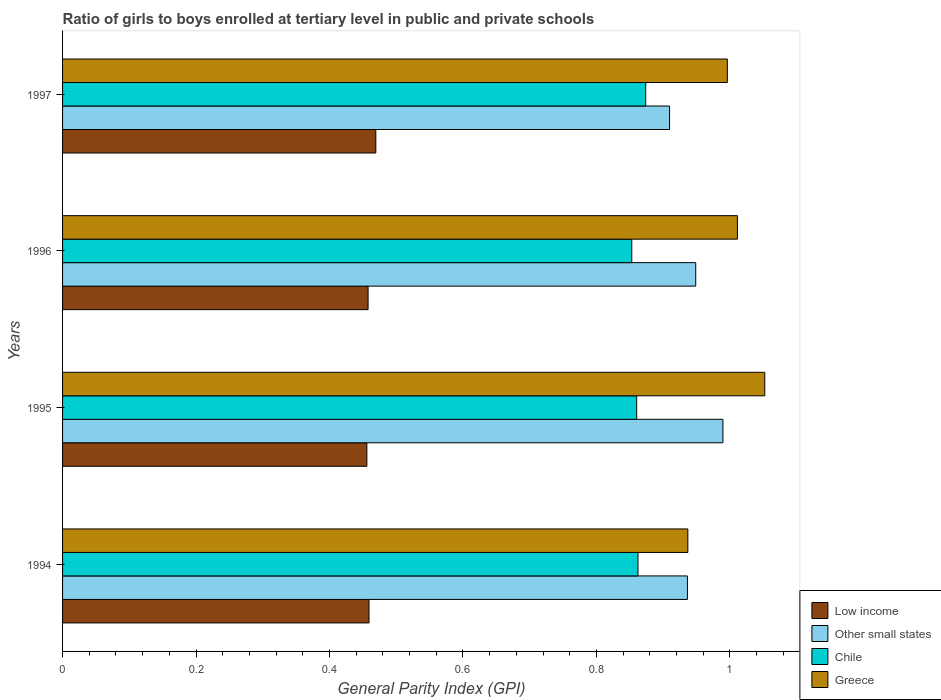Are the number of bars per tick equal to the number of legend labels?
Provide a succinct answer. Yes. Are the number of bars on each tick of the Y-axis equal?
Offer a terse response. Yes. How many bars are there on the 2nd tick from the bottom?
Ensure brevity in your answer.  4. What is the label of the 1st group of bars from the top?
Your response must be concise. 1997. In how many cases, is the number of bars for a given year not equal to the number of legend labels?
Offer a terse response. 0. What is the general parity index in Other small states in 1994?
Provide a succinct answer. 0.94. Across all years, what is the maximum general parity index in Other small states?
Keep it short and to the point. 0.99. Across all years, what is the minimum general parity index in Low income?
Ensure brevity in your answer.  0.46. In which year was the general parity index in Low income maximum?
Provide a succinct answer. 1997. What is the total general parity index in Greece in the graph?
Your answer should be very brief. 4. What is the difference between the general parity index in Other small states in 1994 and that in 1996?
Provide a succinct answer. -0.01. What is the difference between the general parity index in Greece in 1994 and the general parity index in Chile in 1995?
Your answer should be very brief. 0.08. What is the average general parity index in Low income per year?
Offer a terse response. 0.46. In the year 1995, what is the difference between the general parity index in Chile and general parity index in Low income?
Ensure brevity in your answer.  0.4. What is the ratio of the general parity index in Greece in 1996 to that in 1997?
Offer a very short reply. 1.02. Is the general parity index in Greece in 1994 less than that in 1995?
Provide a succinct answer. Yes. What is the difference between the highest and the second highest general parity index in Low income?
Keep it short and to the point. 0.01. What is the difference between the highest and the lowest general parity index in Other small states?
Offer a terse response. 0.08. Is the sum of the general parity index in Low income in 1994 and 1996 greater than the maximum general parity index in Other small states across all years?
Give a very brief answer. No. What does the 2nd bar from the bottom in 1997 represents?
Your answer should be compact. Other small states. Is it the case that in every year, the sum of the general parity index in Chile and general parity index in Other small states is greater than the general parity index in Low income?
Ensure brevity in your answer.  Yes. How many years are there in the graph?
Offer a terse response. 4. Are the values on the major ticks of X-axis written in scientific E-notation?
Make the answer very short. No. Does the graph contain grids?
Your answer should be very brief. No. Where does the legend appear in the graph?
Offer a terse response. Bottom right. How many legend labels are there?
Keep it short and to the point. 4. What is the title of the graph?
Offer a terse response. Ratio of girls to boys enrolled at tertiary level in public and private schools. What is the label or title of the X-axis?
Your response must be concise. General Parity Index (GPI). What is the label or title of the Y-axis?
Offer a very short reply. Years. What is the General Parity Index (GPI) in Low income in 1994?
Provide a short and direct response. 0.46. What is the General Parity Index (GPI) in Other small states in 1994?
Make the answer very short. 0.94. What is the General Parity Index (GPI) of Chile in 1994?
Offer a terse response. 0.86. What is the General Parity Index (GPI) of Greece in 1994?
Your answer should be very brief. 0.94. What is the General Parity Index (GPI) of Low income in 1995?
Offer a very short reply. 0.46. What is the General Parity Index (GPI) in Other small states in 1995?
Provide a succinct answer. 0.99. What is the General Parity Index (GPI) of Chile in 1995?
Give a very brief answer. 0.86. What is the General Parity Index (GPI) of Greece in 1995?
Offer a terse response. 1.05. What is the General Parity Index (GPI) in Low income in 1996?
Give a very brief answer. 0.46. What is the General Parity Index (GPI) of Other small states in 1996?
Your response must be concise. 0.95. What is the General Parity Index (GPI) of Chile in 1996?
Provide a short and direct response. 0.85. What is the General Parity Index (GPI) of Greece in 1996?
Ensure brevity in your answer.  1.01. What is the General Parity Index (GPI) in Low income in 1997?
Keep it short and to the point. 0.47. What is the General Parity Index (GPI) of Other small states in 1997?
Ensure brevity in your answer.  0.91. What is the General Parity Index (GPI) in Chile in 1997?
Your answer should be compact. 0.87. What is the General Parity Index (GPI) of Greece in 1997?
Give a very brief answer. 1. Across all years, what is the maximum General Parity Index (GPI) of Low income?
Provide a short and direct response. 0.47. Across all years, what is the maximum General Parity Index (GPI) of Other small states?
Ensure brevity in your answer.  0.99. Across all years, what is the maximum General Parity Index (GPI) in Chile?
Offer a very short reply. 0.87. Across all years, what is the maximum General Parity Index (GPI) in Greece?
Your answer should be compact. 1.05. Across all years, what is the minimum General Parity Index (GPI) of Low income?
Ensure brevity in your answer.  0.46. Across all years, what is the minimum General Parity Index (GPI) of Other small states?
Offer a very short reply. 0.91. Across all years, what is the minimum General Parity Index (GPI) in Chile?
Give a very brief answer. 0.85. Across all years, what is the minimum General Parity Index (GPI) of Greece?
Give a very brief answer. 0.94. What is the total General Parity Index (GPI) of Low income in the graph?
Give a very brief answer. 1.84. What is the total General Parity Index (GPI) in Other small states in the graph?
Keep it short and to the point. 3.78. What is the total General Parity Index (GPI) in Chile in the graph?
Provide a short and direct response. 3.45. What is the total General Parity Index (GPI) in Greece in the graph?
Provide a short and direct response. 4. What is the difference between the General Parity Index (GPI) of Low income in 1994 and that in 1995?
Ensure brevity in your answer.  0. What is the difference between the General Parity Index (GPI) of Other small states in 1994 and that in 1995?
Provide a short and direct response. -0.05. What is the difference between the General Parity Index (GPI) of Chile in 1994 and that in 1995?
Provide a short and direct response. 0. What is the difference between the General Parity Index (GPI) of Greece in 1994 and that in 1995?
Offer a terse response. -0.12. What is the difference between the General Parity Index (GPI) of Low income in 1994 and that in 1996?
Give a very brief answer. 0. What is the difference between the General Parity Index (GPI) in Other small states in 1994 and that in 1996?
Offer a very short reply. -0.01. What is the difference between the General Parity Index (GPI) of Chile in 1994 and that in 1996?
Keep it short and to the point. 0.01. What is the difference between the General Parity Index (GPI) of Greece in 1994 and that in 1996?
Give a very brief answer. -0.07. What is the difference between the General Parity Index (GPI) in Low income in 1994 and that in 1997?
Ensure brevity in your answer.  -0.01. What is the difference between the General Parity Index (GPI) in Other small states in 1994 and that in 1997?
Provide a succinct answer. 0.03. What is the difference between the General Parity Index (GPI) in Chile in 1994 and that in 1997?
Offer a very short reply. -0.01. What is the difference between the General Parity Index (GPI) of Greece in 1994 and that in 1997?
Provide a succinct answer. -0.06. What is the difference between the General Parity Index (GPI) of Low income in 1995 and that in 1996?
Make the answer very short. -0. What is the difference between the General Parity Index (GPI) of Other small states in 1995 and that in 1996?
Keep it short and to the point. 0.04. What is the difference between the General Parity Index (GPI) in Chile in 1995 and that in 1996?
Your answer should be very brief. 0.01. What is the difference between the General Parity Index (GPI) of Greece in 1995 and that in 1996?
Make the answer very short. 0.04. What is the difference between the General Parity Index (GPI) in Low income in 1995 and that in 1997?
Ensure brevity in your answer.  -0.01. What is the difference between the General Parity Index (GPI) in Other small states in 1995 and that in 1997?
Offer a terse response. 0.08. What is the difference between the General Parity Index (GPI) in Chile in 1995 and that in 1997?
Keep it short and to the point. -0.01. What is the difference between the General Parity Index (GPI) in Greece in 1995 and that in 1997?
Ensure brevity in your answer.  0.06. What is the difference between the General Parity Index (GPI) in Low income in 1996 and that in 1997?
Provide a succinct answer. -0.01. What is the difference between the General Parity Index (GPI) of Other small states in 1996 and that in 1997?
Ensure brevity in your answer.  0.04. What is the difference between the General Parity Index (GPI) of Chile in 1996 and that in 1997?
Your answer should be compact. -0.02. What is the difference between the General Parity Index (GPI) of Greece in 1996 and that in 1997?
Make the answer very short. 0.02. What is the difference between the General Parity Index (GPI) of Low income in 1994 and the General Parity Index (GPI) of Other small states in 1995?
Provide a short and direct response. -0.53. What is the difference between the General Parity Index (GPI) in Low income in 1994 and the General Parity Index (GPI) in Chile in 1995?
Offer a terse response. -0.4. What is the difference between the General Parity Index (GPI) of Low income in 1994 and the General Parity Index (GPI) of Greece in 1995?
Your answer should be compact. -0.59. What is the difference between the General Parity Index (GPI) in Other small states in 1994 and the General Parity Index (GPI) in Chile in 1995?
Your answer should be very brief. 0.08. What is the difference between the General Parity Index (GPI) in Other small states in 1994 and the General Parity Index (GPI) in Greece in 1995?
Provide a short and direct response. -0.12. What is the difference between the General Parity Index (GPI) in Chile in 1994 and the General Parity Index (GPI) in Greece in 1995?
Offer a terse response. -0.19. What is the difference between the General Parity Index (GPI) of Low income in 1994 and the General Parity Index (GPI) of Other small states in 1996?
Provide a succinct answer. -0.49. What is the difference between the General Parity Index (GPI) in Low income in 1994 and the General Parity Index (GPI) in Chile in 1996?
Your answer should be very brief. -0.39. What is the difference between the General Parity Index (GPI) in Low income in 1994 and the General Parity Index (GPI) in Greece in 1996?
Your response must be concise. -0.55. What is the difference between the General Parity Index (GPI) in Other small states in 1994 and the General Parity Index (GPI) in Chile in 1996?
Keep it short and to the point. 0.08. What is the difference between the General Parity Index (GPI) in Other small states in 1994 and the General Parity Index (GPI) in Greece in 1996?
Offer a terse response. -0.07. What is the difference between the General Parity Index (GPI) of Chile in 1994 and the General Parity Index (GPI) of Greece in 1996?
Ensure brevity in your answer.  -0.15. What is the difference between the General Parity Index (GPI) in Low income in 1994 and the General Parity Index (GPI) in Other small states in 1997?
Offer a very short reply. -0.45. What is the difference between the General Parity Index (GPI) in Low income in 1994 and the General Parity Index (GPI) in Chile in 1997?
Keep it short and to the point. -0.41. What is the difference between the General Parity Index (GPI) in Low income in 1994 and the General Parity Index (GPI) in Greece in 1997?
Keep it short and to the point. -0.54. What is the difference between the General Parity Index (GPI) in Other small states in 1994 and the General Parity Index (GPI) in Chile in 1997?
Provide a succinct answer. 0.06. What is the difference between the General Parity Index (GPI) of Other small states in 1994 and the General Parity Index (GPI) of Greece in 1997?
Offer a terse response. -0.06. What is the difference between the General Parity Index (GPI) in Chile in 1994 and the General Parity Index (GPI) in Greece in 1997?
Offer a terse response. -0.13. What is the difference between the General Parity Index (GPI) of Low income in 1995 and the General Parity Index (GPI) of Other small states in 1996?
Make the answer very short. -0.49. What is the difference between the General Parity Index (GPI) in Low income in 1995 and the General Parity Index (GPI) in Chile in 1996?
Offer a terse response. -0.4. What is the difference between the General Parity Index (GPI) of Low income in 1995 and the General Parity Index (GPI) of Greece in 1996?
Your answer should be compact. -0.56. What is the difference between the General Parity Index (GPI) of Other small states in 1995 and the General Parity Index (GPI) of Chile in 1996?
Offer a terse response. 0.14. What is the difference between the General Parity Index (GPI) in Other small states in 1995 and the General Parity Index (GPI) in Greece in 1996?
Your answer should be compact. -0.02. What is the difference between the General Parity Index (GPI) of Chile in 1995 and the General Parity Index (GPI) of Greece in 1996?
Make the answer very short. -0.15. What is the difference between the General Parity Index (GPI) in Low income in 1995 and the General Parity Index (GPI) in Other small states in 1997?
Provide a succinct answer. -0.45. What is the difference between the General Parity Index (GPI) in Low income in 1995 and the General Parity Index (GPI) in Chile in 1997?
Give a very brief answer. -0.42. What is the difference between the General Parity Index (GPI) in Low income in 1995 and the General Parity Index (GPI) in Greece in 1997?
Provide a short and direct response. -0.54. What is the difference between the General Parity Index (GPI) of Other small states in 1995 and the General Parity Index (GPI) of Chile in 1997?
Offer a very short reply. 0.12. What is the difference between the General Parity Index (GPI) in Other small states in 1995 and the General Parity Index (GPI) in Greece in 1997?
Your answer should be compact. -0.01. What is the difference between the General Parity Index (GPI) in Chile in 1995 and the General Parity Index (GPI) in Greece in 1997?
Make the answer very short. -0.14. What is the difference between the General Parity Index (GPI) of Low income in 1996 and the General Parity Index (GPI) of Other small states in 1997?
Keep it short and to the point. -0.45. What is the difference between the General Parity Index (GPI) of Low income in 1996 and the General Parity Index (GPI) of Chile in 1997?
Your answer should be compact. -0.42. What is the difference between the General Parity Index (GPI) in Low income in 1996 and the General Parity Index (GPI) in Greece in 1997?
Offer a terse response. -0.54. What is the difference between the General Parity Index (GPI) of Other small states in 1996 and the General Parity Index (GPI) of Chile in 1997?
Your answer should be compact. 0.07. What is the difference between the General Parity Index (GPI) in Other small states in 1996 and the General Parity Index (GPI) in Greece in 1997?
Ensure brevity in your answer.  -0.05. What is the difference between the General Parity Index (GPI) in Chile in 1996 and the General Parity Index (GPI) in Greece in 1997?
Your response must be concise. -0.14. What is the average General Parity Index (GPI) of Low income per year?
Provide a short and direct response. 0.46. What is the average General Parity Index (GPI) of Other small states per year?
Provide a succinct answer. 0.95. What is the average General Parity Index (GPI) in Chile per year?
Ensure brevity in your answer.  0.86. In the year 1994, what is the difference between the General Parity Index (GPI) in Low income and General Parity Index (GPI) in Other small states?
Your response must be concise. -0.48. In the year 1994, what is the difference between the General Parity Index (GPI) in Low income and General Parity Index (GPI) in Chile?
Your answer should be very brief. -0.4. In the year 1994, what is the difference between the General Parity Index (GPI) of Low income and General Parity Index (GPI) of Greece?
Offer a very short reply. -0.48. In the year 1994, what is the difference between the General Parity Index (GPI) in Other small states and General Parity Index (GPI) in Chile?
Keep it short and to the point. 0.07. In the year 1994, what is the difference between the General Parity Index (GPI) of Other small states and General Parity Index (GPI) of Greece?
Provide a short and direct response. -0. In the year 1994, what is the difference between the General Parity Index (GPI) in Chile and General Parity Index (GPI) in Greece?
Offer a very short reply. -0.07. In the year 1995, what is the difference between the General Parity Index (GPI) in Low income and General Parity Index (GPI) in Other small states?
Your response must be concise. -0.53. In the year 1995, what is the difference between the General Parity Index (GPI) in Low income and General Parity Index (GPI) in Chile?
Provide a succinct answer. -0.4. In the year 1995, what is the difference between the General Parity Index (GPI) in Low income and General Parity Index (GPI) in Greece?
Offer a terse response. -0.6. In the year 1995, what is the difference between the General Parity Index (GPI) in Other small states and General Parity Index (GPI) in Chile?
Provide a short and direct response. 0.13. In the year 1995, what is the difference between the General Parity Index (GPI) of Other small states and General Parity Index (GPI) of Greece?
Provide a succinct answer. -0.06. In the year 1995, what is the difference between the General Parity Index (GPI) in Chile and General Parity Index (GPI) in Greece?
Offer a terse response. -0.19. In the year 1996, what is the difference between the General Parity Index (GPI) of Low income and General Parity Index (GPI) of Other small states?
Give a very brief answer. -0.49. In the year 1996, what is the difference between the General Parity Index (GPI) of Low income and General Parity Index (GPI) of Chile?
Offer a terse response. -0.4. In the year 1996, what is the difference between the General Parity Index (GPI) of Low income and General Parity Index (GPI) of Greece?
Ensure brevity in your answer.  -0.55. In the year 1996, what is the difference between the General Parity Index (GPI) of Other small states and General Parity Index (GPI) of Chile?
Keep it short and to the point. 0.1. In the year 1996, what is the difference between the General Parity Index (GPI) of Other small states and General Parity Index (GPI) of Greece?
Give a very brief answer. -0.06. In the year 1996, what is the difference between the General Parity Index (GPI) in Chile and General Parity Index (GPI) in Greece?
Ensure brevity in your answer.  -0.16. In the year 1997, what is the difference between the General Parity Index (GPI) of Low income and General Parity Index (GPI) of Other small states?
Provide a short and direct response. -0.44. In the year 1997, what is the difference between the General Parity Index (GPI) of Low income and General Parity Index (GPI) of Chile?
Give a very brief answer. -0.4. In the year 1997, what is the difference between the General Parity Index (GPI) of Low income and General Parity Index (GPI) of Greece?
Provide a short and direct response. -0.53. In the year 1997, what is the difference between the General Parity Index (GPI) of Other small states and General Parity Index (GPI) of Chile?
Offer a terse response. 0.04. In the year 1997, what is the difference between the General Parity Index (GPI) of Other small states and General Parity Index (GPI) of Greece?
Make the answer very short. -0.09. In the year 1997, what is the difference between the General Parity Index (GPI) of Chile and General Parity Index (GPI) of Greece?
Make the answer very short. -0.12. What is the ratio of the General Parity Index (GPI) of Low income in 1994 to that in 1995?
Make the answer very short. 1.01. What is the ratio of the General Parity Index (GPI) of Other small states in 1994 to that in 1995?
Offer a very short reply. 0.95. What is the ratio of the General Parity Index (GPI) in Greece in 1994 to that in 1995?
Your response must be concise. 0.89. What is the ratio of the General Parity Index (GPI) of Low income in 1994 to that in 1996?
Keep it short and to the point. 1. What is the ratio of the General Parity Index (GPI) in Other small states in 1994 to that in 1996?
Ensure brevity in your answer.  0.99. What is the ratio of the General Parity Index (GPI) of Chile in 1994 to that in 1996?
Offer a terse response. 1.01. What is the ratio of the General Parity Index (GPI) in Greece in 1994 to that in 1996?
Ensure brevity in your answer.  0.93. What is the ratio of the General Parity Index (GPI) of Low income in 1994 to that in 1997?
Provide a short and direct response. 0.98. What is the ratio of the General Parity Index (GPI) in Other small states in 1994 to that in 1997?
Provide a succinct answer. 1.03. What is the ratio of the General Parity Index (GPI) of Chile in 1994 to that in 1997?
Offer a very short reply. 0.99. What is the ratio of the General Parity Index (GPI) in Greece in 1994 to that in 1997?
Make the answer very short. 0.94. What is the ratio of the General Parity Index (GPI) of Other small states in 1995 to that in 1996?
Ensure brevity in your answer.  1.04. What is the ratio of the General Parity Index (GPI) of Chile in 1995 to that in 1996?
Your answer should be compact. 1.01. What is the ratio of the General Parity Index (GPI) in Greece in 1995 to that in 1996?
Provide a short and direct response. 1.04. What is the ratio of the General Parity Index (GPI) of Low income in 1995 to that in 1997?
Your answer should be compact. 0.97. What is the ratio of the General Parity Index (GPI) in Other small states in 1995 to that in 1997?
Ensure brevity in your answer.  1.09. What is the ratio of the General Parity Index (GPI) in Chile in 1995 to that in 1997?
Offer a terse response. 0.98. What is the ratio of the General Parity Index (GPI) of Greece in 1995 to that in 1997?
Offer a very short reply. 1.06. What is the ratio of the General Parity Index (GPI) in Low income in 1996 to that in 1997?
Ensure brevity in your answer.  0.98. What is the ratio of the General Parity Index (GPI) in Other small states in 1996 to that in 1997?
Offer a very short reply. 1.04. What is the ratio of the General Parity Index (GPI) in Chile in 1996 to that in 1997?
Give a very brief answer. 0.98. What is the ratio of the General Parity Index (GPI) of Greece in 1996 to that in 1997?
Provide a short and direct response. 1.02. What is the difference between the highest and the second highest General Parity Index (GPI) of Low income?
Make the answer very short. 0.01. What is the difference between the highest and the second highest General Parity Index (GPI) in Other small states?
Your answer should be very brief. 0.04. What is the difference between the highest and the second highest General Parity Index (GPI) in Chile?
Offer a very short reply. 0.01. What is the difference between the highest and the second highest General Parity Index (GPI) of Greece?
Offer a very short reply. 0.04. What is the difference between the highest and the lowest General Parity Index (GPI) in Low income?
Make the answer very short. 0.01. What is the difference between the highest and the lowest General Parity Index (GPI) of Other small states?
Keep it short and to the point. 0.08. What is the difference between the highest and the lowest General Parity Index (GPI) in Chile?
Ensure brevity in your answer.  0.02. What is the difference between the highest and the lowest General Parity Index (GPI) of Greece?
Your answer should be very brief. 0.12. 